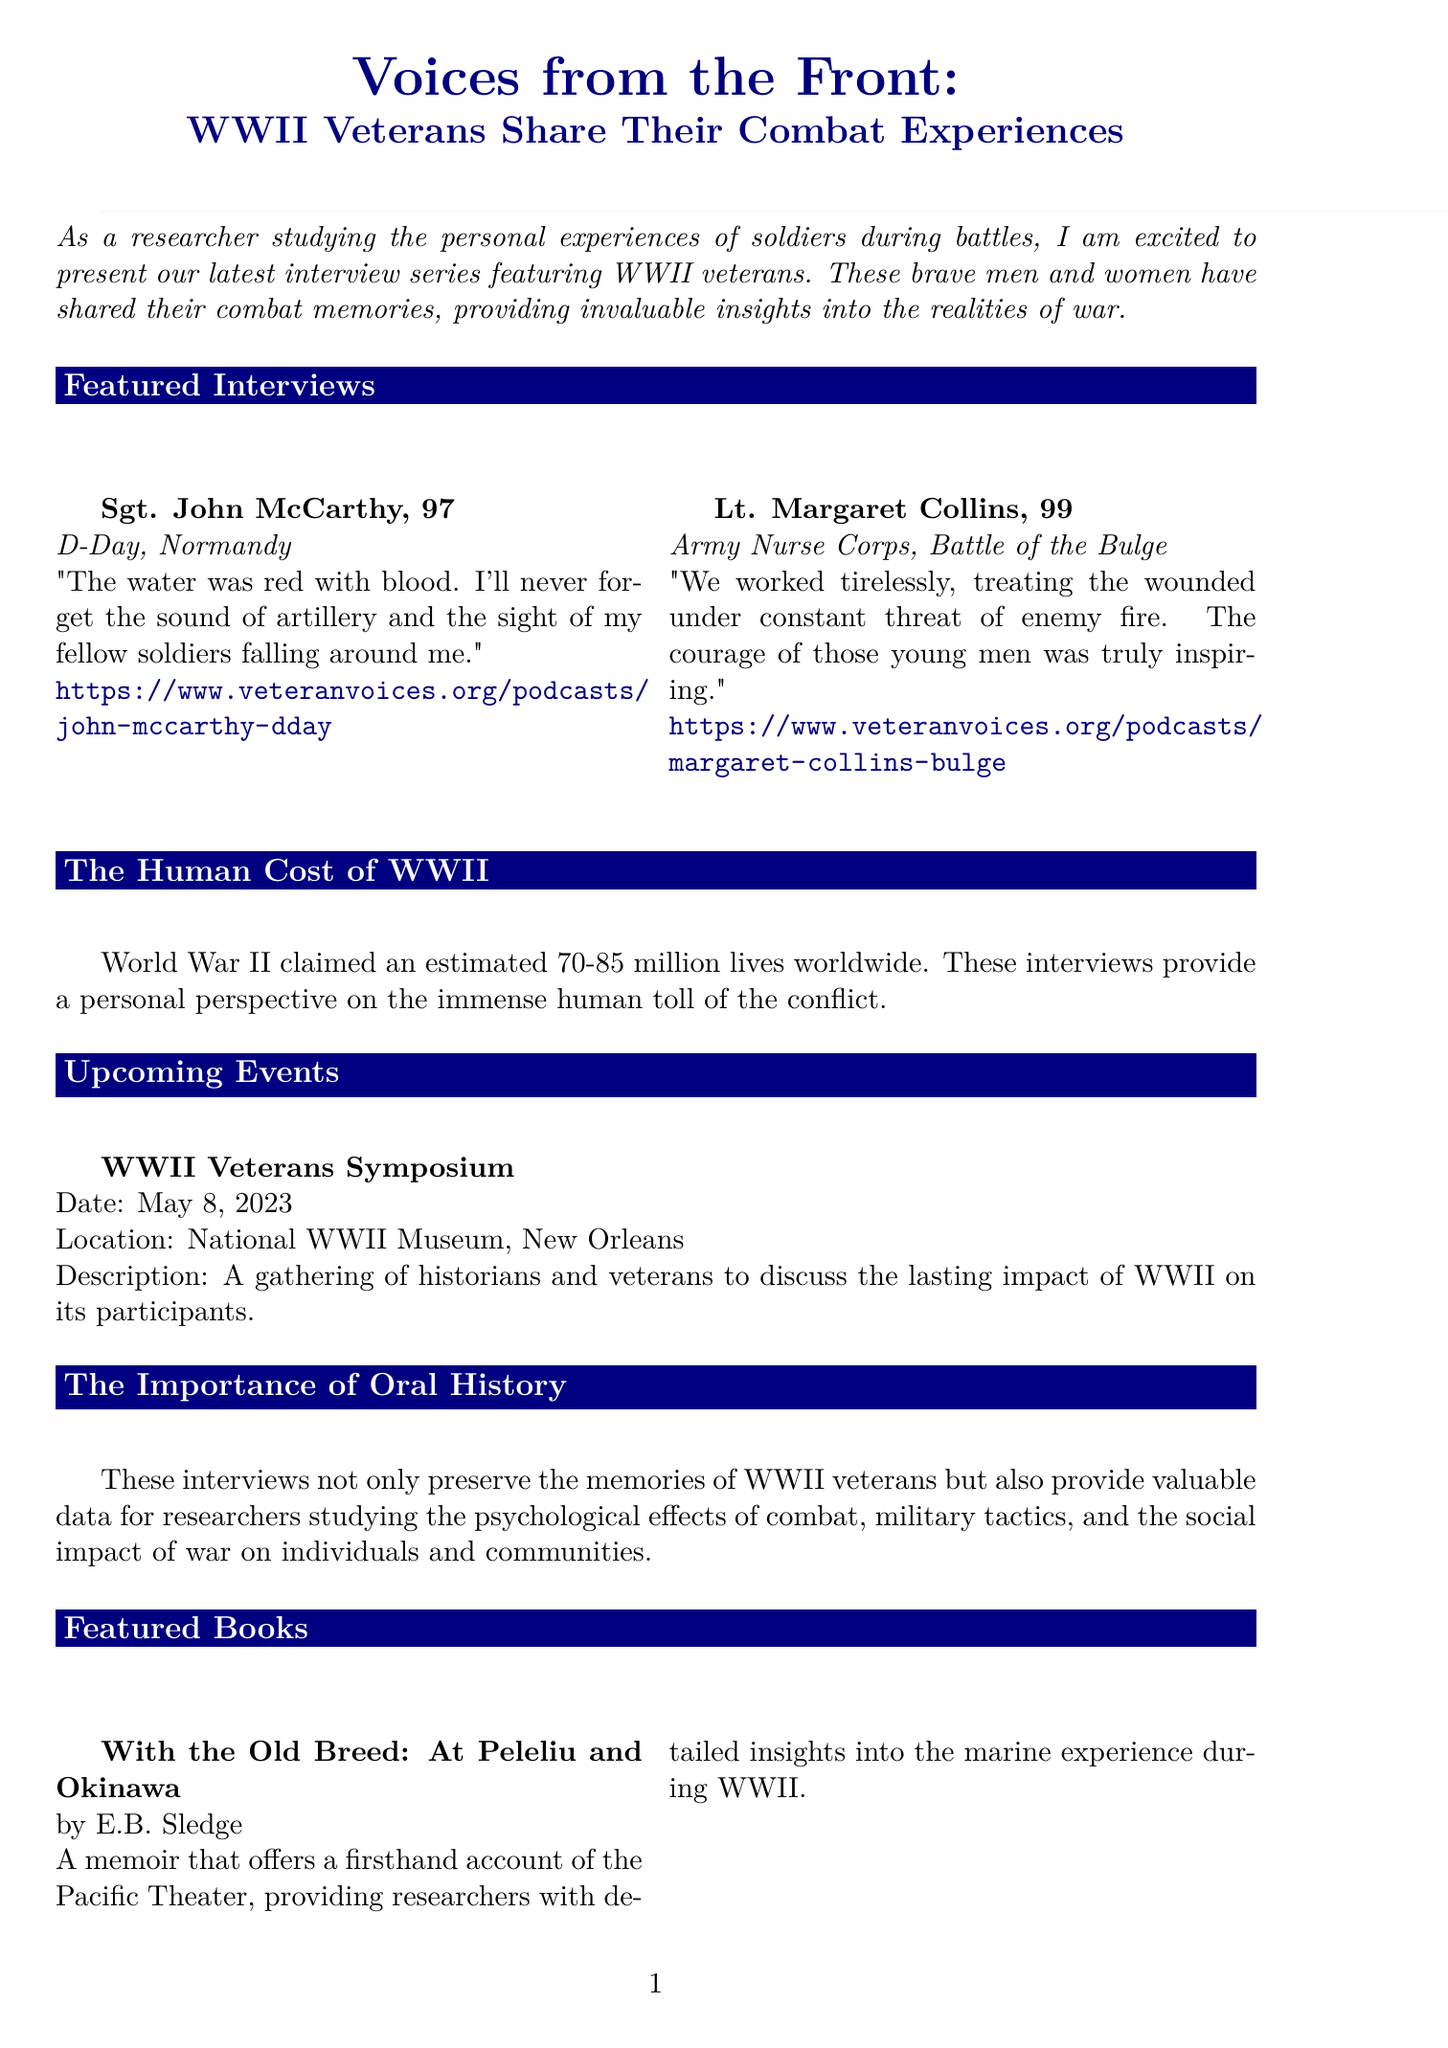What is the title of the newsletter? The title of the newsletter is stated at the beginning of the document.
Answer: Voices from the Front: WWII Veterans Share Their Combat Experiences Who is featured in the first interview? The first interview features Sgt. John McCarthy as mentioned in the featured interviews section.
Answer: Sgt. John McCarthy What battle did Lt. Margaret Collins participate in? The document specifies that Lt. Margaret Collins was involved in the Battle of the Bulge.
Answer: Battle of the Bulge How old is Sgt. John McCarthy? The document explicitly states the age of Sgt. John McCarthy in the featured interviews section.
Answer: 97 What significant event is scheduled for May 8, 2023? The document details an upcoming event related to WWII veterans happening on May 8, 2023.
Answer: WWII Veterans Symposium What is the main theme of the historical context section? The historical context discusses the human toll of World War II, as illustrated in the document.
Answer: The Human Cost of WWII Which book is authored by Stephen E. Ambrose? The document lists two featured books, indicating which author wrote which book.
Answer: Band of Brothers What is the purpose of the call to action? The call to action invites WWII veterans to share their stories for historical preservation.
Answer: Help Preserve History 